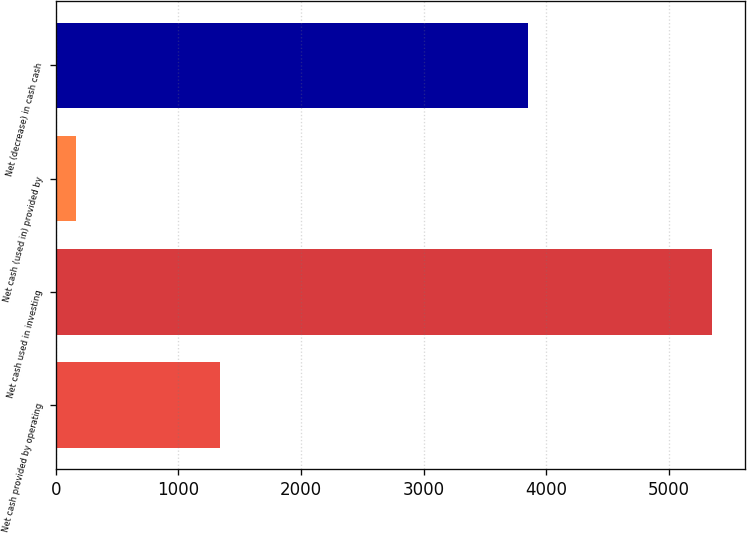Convert chart to OTSL. <chart><loc_0><loc_0><loc_500><loc_500><bar_chart><fcel>Net cash provided by operating<fcel>Net cash used in investing<fcel>Net cash (used in) provided by<fcel>Net (decrease) in cash cash<nl><fcel>1335<fcel>5349<fcel>164<fcel>3850<nl></chart> 